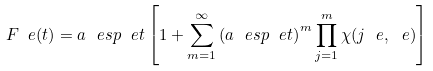<formula> <loc_0><loc_0><loc_500><loc_500>\ F _ { \ } e ( t ) = a \ e s p { \ e t } \left [ 1 + \sum _ { m = 1 } ^ { \infty } \left ( a \ e s p { \ e t } \right ) ^ { m } \prod _ { j = 1 } ^ { m } \chi ( j \ e , \ e ) \right ]</formula> 